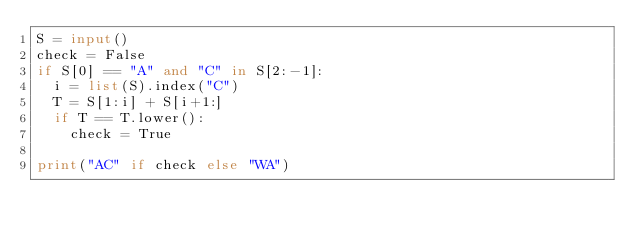<code> <loc_0><loc_0><loc_500><loc_500><_Python_>S = input()
check = False
if S[0] == "A" and "C" in S[2:-1]:
  i = list(S).index("C")
  T = S[1:i] + S[i+1:]
  if T == T.lower():
    check = True
    
print("AC" if check else "WA")  </code> 